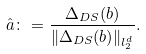<formula> <loc_0><loc_0><loc_500><loc_500>\hat { a } \colon = \frac { \Delta _ { D S } ( b ) } { \| \Delta _ { D S } ( b ) \| _ { l _ { 2 } ^ { d } } } .</formula> 